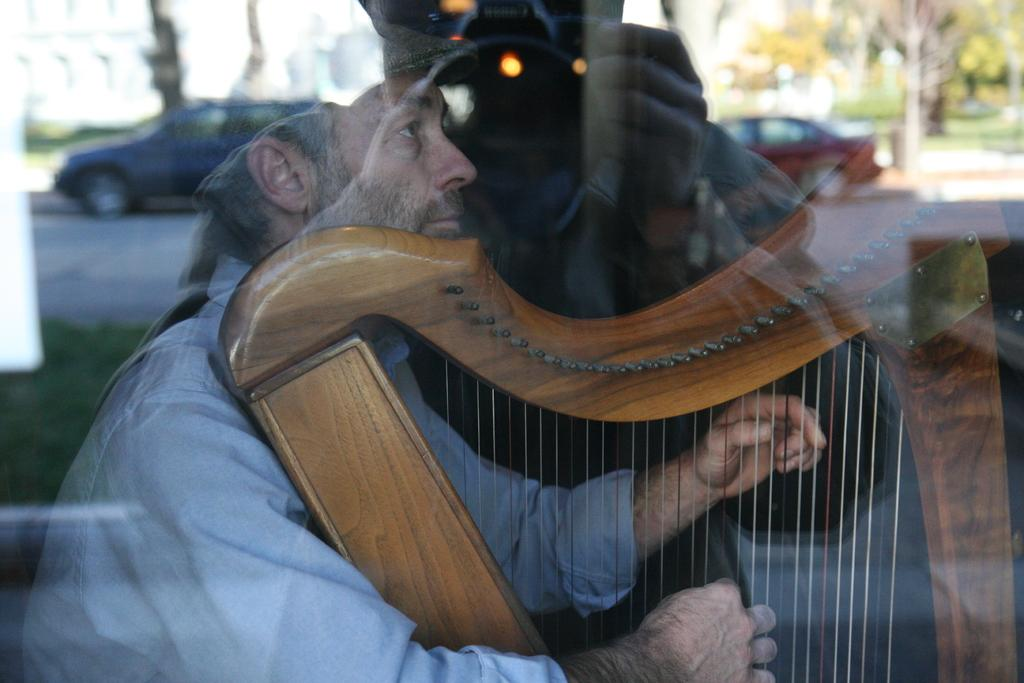What is the person in the image doing? The person in the image is playing a musical instrument. What object can be seen in the image besides the musical instrument? There is a glass in the image. What can be seen in the reflection of the glass? The glass contains a reflection of a person, cars, and trees. What type of power is being generated by the person playing the musical instrument in the image? The person playing the musical instrument is not generating any power in the image. 